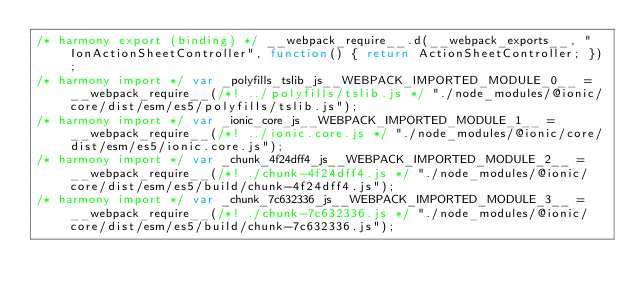<code> <loc_0><loc_0><loc_500><loc_500><_JavaScript_>/* harmony export (binding) */ __webpack_require__.d(__webpack_exports__, "IonActionSheetController", function() { return ActionSheetController; });
/* harmony import */ var _polyfills_tslib_js__WEBPACK_IMPORTED_MODULE_0__ = __webpack_require__(/*! ../polyfills/tslib.js */ "./node_modules/@ionic/core/dist/esm/es5/polyfills/tslib.js");
/* harmony import */ var _ionic_core_js__WEBPACK_IMPORTED_MODULE_1__ = __webpack_require__(/*! ../ionic.core.js */ "./node_modules/@ionic/core/dist/esm/es5/ionic.core.js");
/* harmony import */ var _chunk_4f24dff4_js__WEBPACK_IMPORTED_MODULE_2__ = __webpack_require__(/*! ./chunk-4f24dff4.js */ "./node_modules/@ionic/core/dist/esm/es5/build/chunk-4f24dff4.js");
/* harmony import */ var _chunk_7c632336_js__WEBPACK_IMPORTED_MODULE_3__ = __webpack_require__(/*! ./chunk-7c632336.js */ "./node_modules/@ionic/core/dist/esm/es5/build/chunk-7c632336.js");</code> 